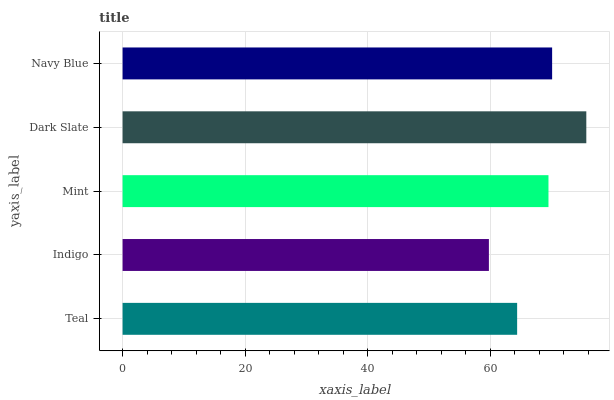Is Indigo the minimum?
Answer yes or no. Yes. Is Dark Slate the maximum?
Answer yes or no. Yes. Is Mint the minimum?
Answer yes or no. No. Is Mint the maximum?
Answer yes or no. No. Is Mint greater than Indigo?
Answer yes or no. Yes. Is Indigo less than Mint?
Answer yes or no. Yes. Is Indigo greater than Mint?
Answer yes or no. No. Is Mint less than Indigo?
Answer yes or no. No. Is Mint the high median?
Answer yes or no. Yes. Is Mint the low median?
Answer yes or no. Yes. Is Navy Blue the high median?
Answer yes or no. No. Is Navy Blue the low median?
Answer yes or no. No. 